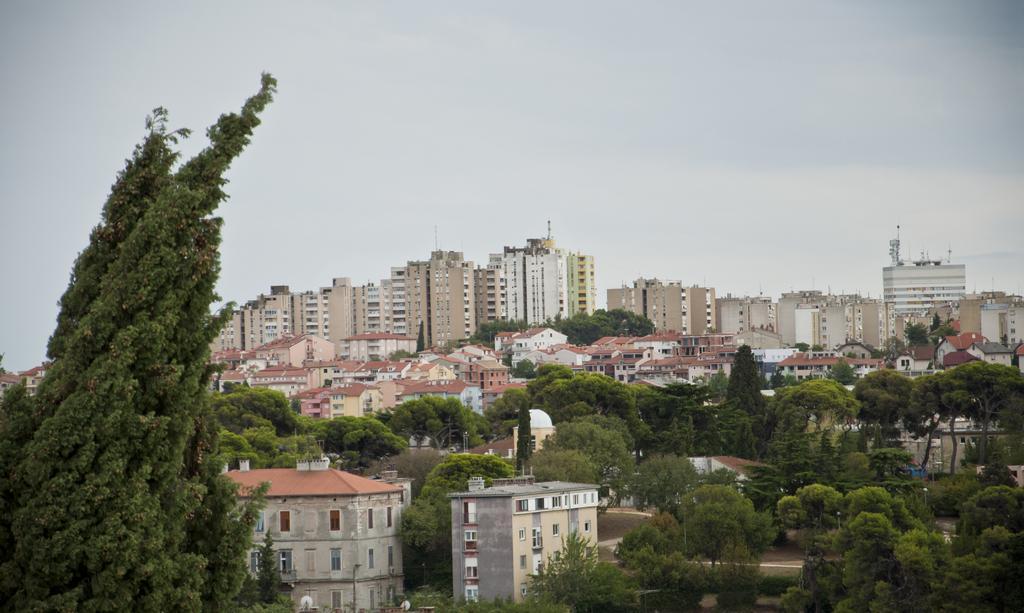Could you give a brief overview of what you see in this image? This is a picture of a city. In the foreground of the picture there are trees, buildings. Sky is cloudy. 